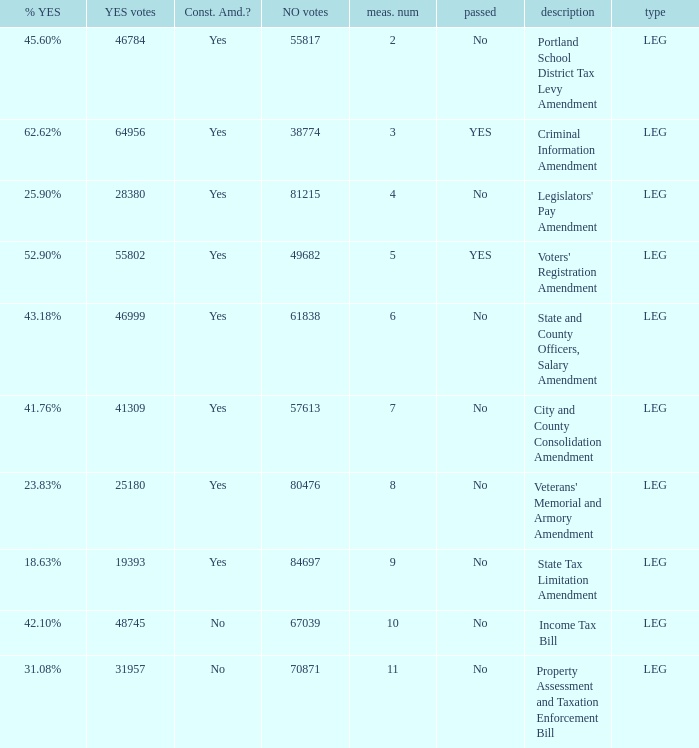HOw many no votes were there when there were 45.60% yes votes 55817.0. 